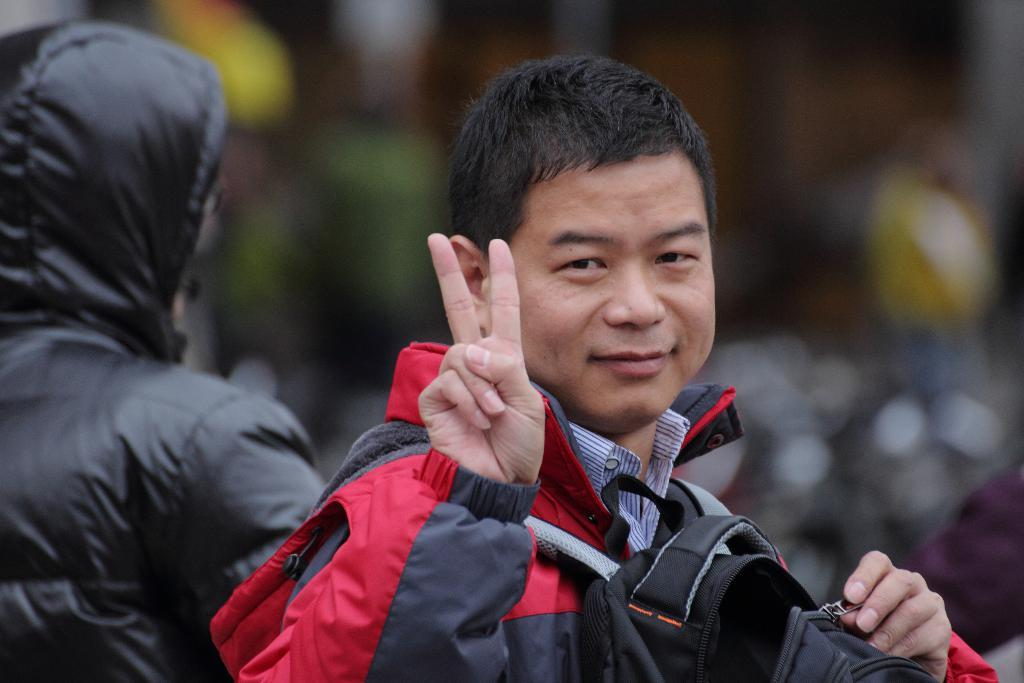How many people are in the image? There are a few people in the image. What is one person doing with an object in the image? One person is holding a bag on his shoulder. Can you describe the background of the image? The background of the image is blurry. What type of glue is being used by the person in the image? There is no glue present in the image, and therefore no such activity can be observed. What kind of teeth can be seen in the image? There are no teeth visible in the image. 